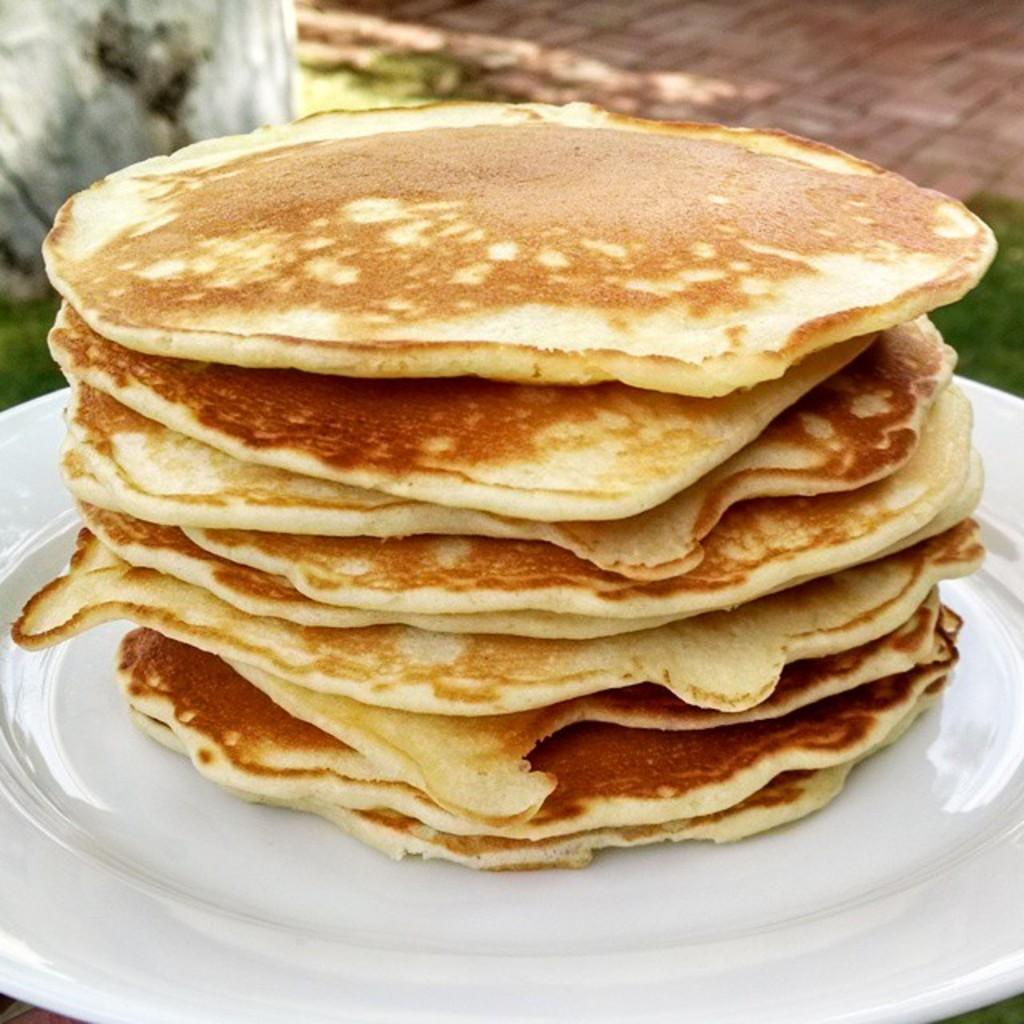Where was the image taken? The image was taken outdoors. What is the main subject of the image? There are pancakes on a platter in the middle of the image. What type of surface is visible at the top of the image? There is a floor visible at the top of the image. What is the natural environment like in the image? There is ground with grass in the image. How many eggs are visible in the image? There are no eggs visible in the image. What type of wind can be seen blowing through the image? There is no wind visible in the image, and the term "zephyr" refers to a gentle breeze, which cannot be seen. 